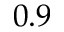<formula> <loc_0><loc_0><loc_500><loc_500>0 . 9</formula> 